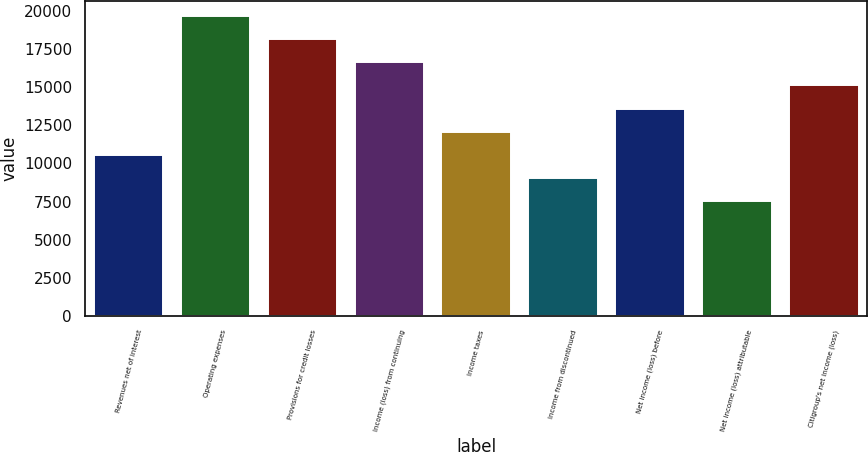Convert chart to OTSL. <chart><loc_0><loc_0><loc_500><loc_500><bar_chart><fcel>Revenues net of interest<fcel>Operating expenses<fcel>Provisions for credit losses<fcel>Income (loss) from continuing<fcel>Income taxes<fcel>Income from discontinued<fcel>Net income (loss) before<fcel>Net income (loss) attributable<fcel>Citigroup's net income (loss)<nl><fcel>10565.2<fcel>19620.8<fcel>18111.6<fcel>16602.3<fcel>12074.5<fcel>9055.95<fcel>13583.8<fcel>7546.68<fcel>15093<nl></chart> 